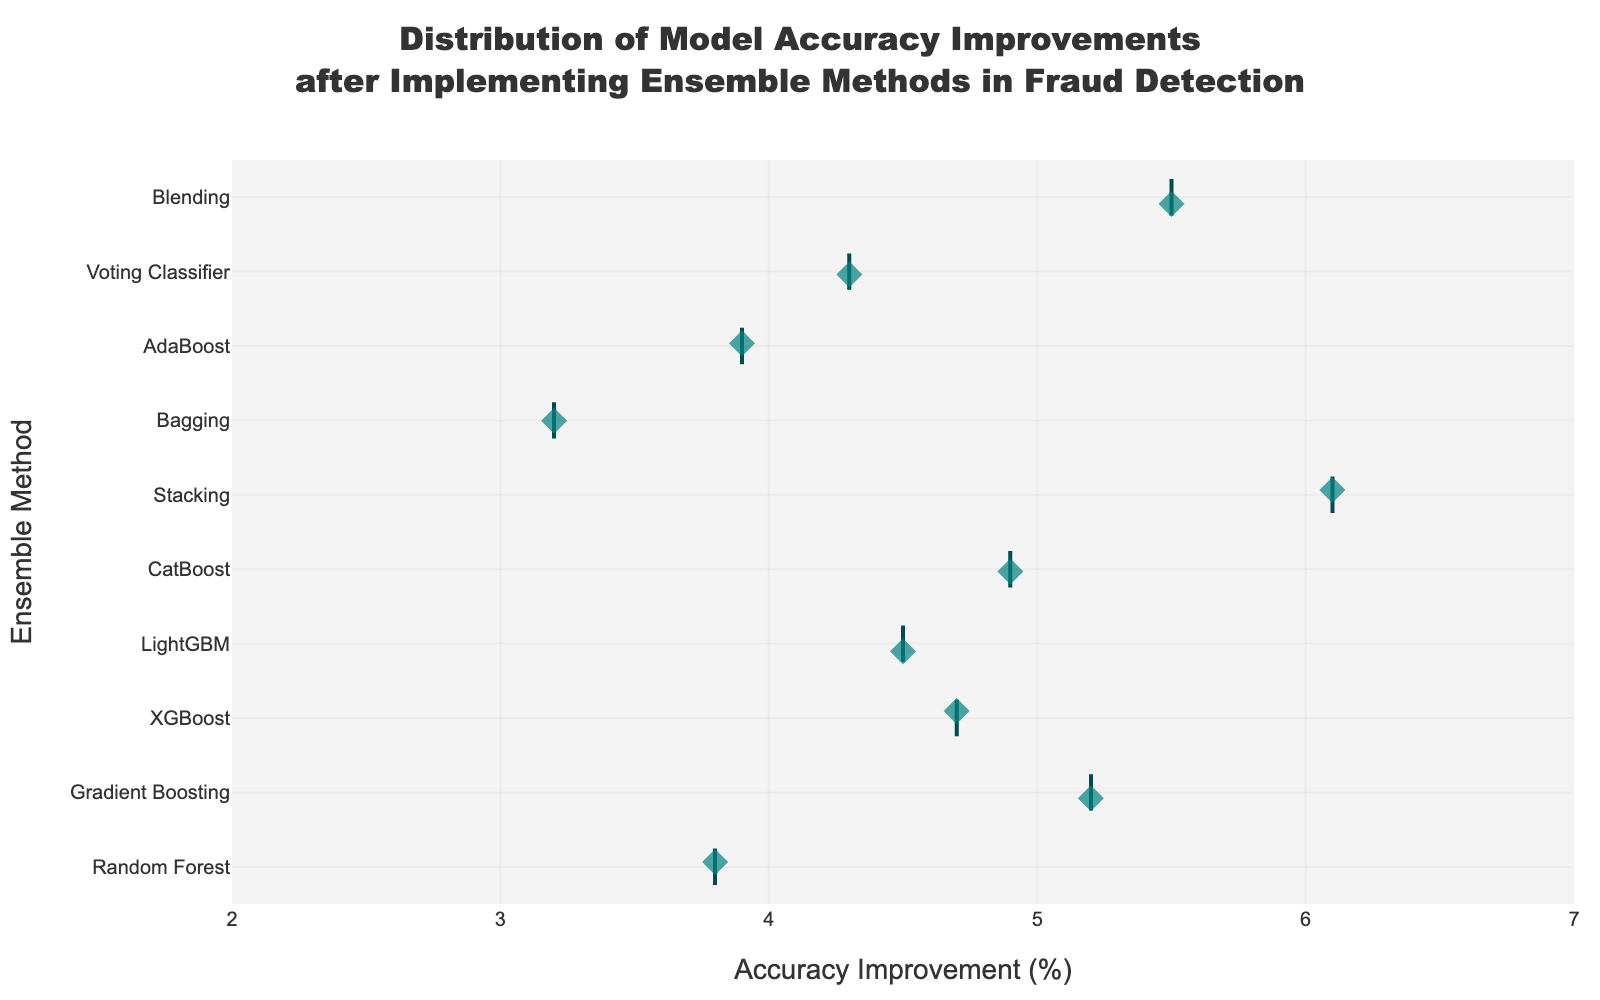What is the title of the figure? The title is located at the top of the figure, providing an overview of what the plot represents. It helps viewers quickly understand the context of the visualized data.
Answer: Distribution of Model Accuracy Improvements after Implementing Ensemble Methods in Fraud Detection Which ensemble method shows the highest accuracy improvement? By inspecting the strip plot, we can see which data point has the highest value on the horizontal axis.
Answer: Stacking Which ensemble method has the lowest accuracy improvement? By looking at the lowest point on the horizontal axis, we can determine which model has the minimum improvement.
Answer: Bagging What is the range of accuracy improvements for the ensemble methods? From the axis ticks, we can see the minimum and maximum values of accuracy improvements.
Answer: 3.2 to 6.1 What is the average improvement among the given ensemble methods? Calculate the mean by summing up all the accuracy improvements and dividing by the number of data points. \( \frac{3.8 + 5.2 + 4.7 + 4.5 + 4.9 + 6.1 + 3.2 + 3.9 + 4.3 + 5.5}{10} = \frac{46.1}{10} \)
Answer: 4.61 How many ensemble methods have an accuracy improvement greater than 5%? Count the number of data points to the right of the 5% mark on the horizontal axis.
Answer: 3 Which ensemble methods have accuracy improvements between 4% and 5%? Identify the points within the given range on the horizontal axis and list the corresponding models.
Answer: XGBoost, LightGBM, Voting Classifier Compare the accuracy improvements of XGBoost and LightGBM. Which one is higher? By comparing the positions of the XGBoost and LightGBM data points on the horizontal axis, we can determine which one has a higher value.
Answer: XGBoost What can you say about the distribution of accuracy improvements from the ensemble methods? By observing the scatter of points across the horizontal axis, we can comment on the spread and whether there are any noticeable clusters or outliers.
Answer: The accuracy improvements are fairly spread out between 3.2% and 6.1% Are there any models with the same accuracy improvement? By looking at the points closely, we can see if any two or more points overlap exactly on the horizontal axis.
Answer: No 